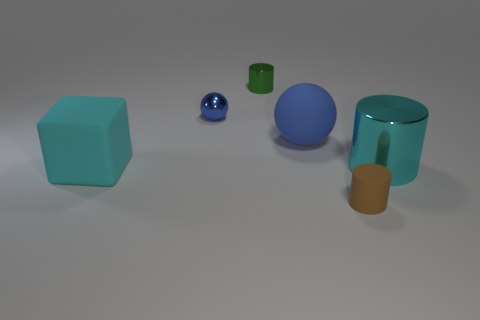What number of other things are there of the same material as the big blue object
Your response must be concise. 2. What number of other things are there of the same color as the large cube?
Your answer should be compact. 1. What material is the small object in front of the big cyan thing on the left side of the tiny green metal thing made of?
Your answer should be compact. Rubber. Are there any small blue metal cylinders?
Give a very brief answer. No. What is the size of the object to the right of the small brown cylinder in front of the cyan cylinder?
Provide a short and direct response. Large. Are there more tiny green cylinders right of the big cyan matte object than cyan matte things that are behind the green thing?
Your response must be concise. Yes. What number of spheres are either big metallic objects or tiny blue shiny things?
Your answer should be compact. 1. There is a blue metal object that is behind the large shiny cylinder; is its shape the same as the blue matte object?
Ensure brevity in your answer.  Yes. The big metallic object is what color?
Provide a succinct answer. Cyan. There is a rubber object that is the same shape as the tiny blue shiny object; what color is it?
Offer a very short reply. Blue. 